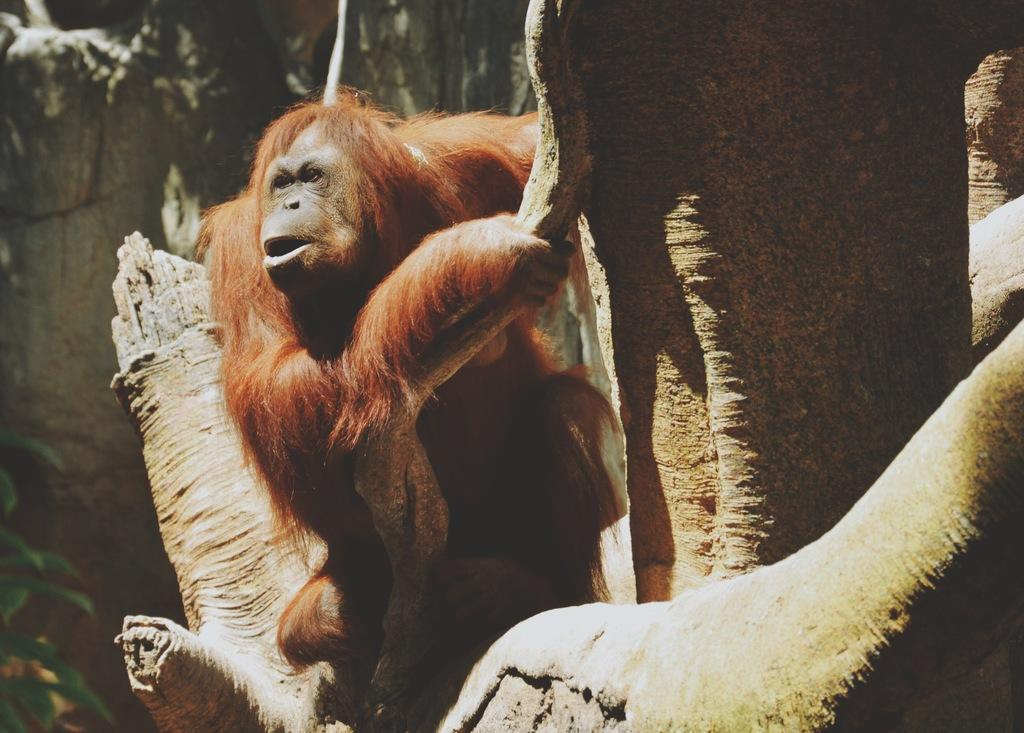What animal is present in the image? There is an orangutan in the image. Where is the orangutan located? The orangutan is on a tree. What can be seen in the background of the image? There is a plant in the background of the image. How many horses are visible in the image? There are no horses present in the image; it features an orangutan on a tree. What type of cup is being used by the orangutan in the image? There is no cup present in the image; the orangutan is on a tree and there are no other objects mentioned. 